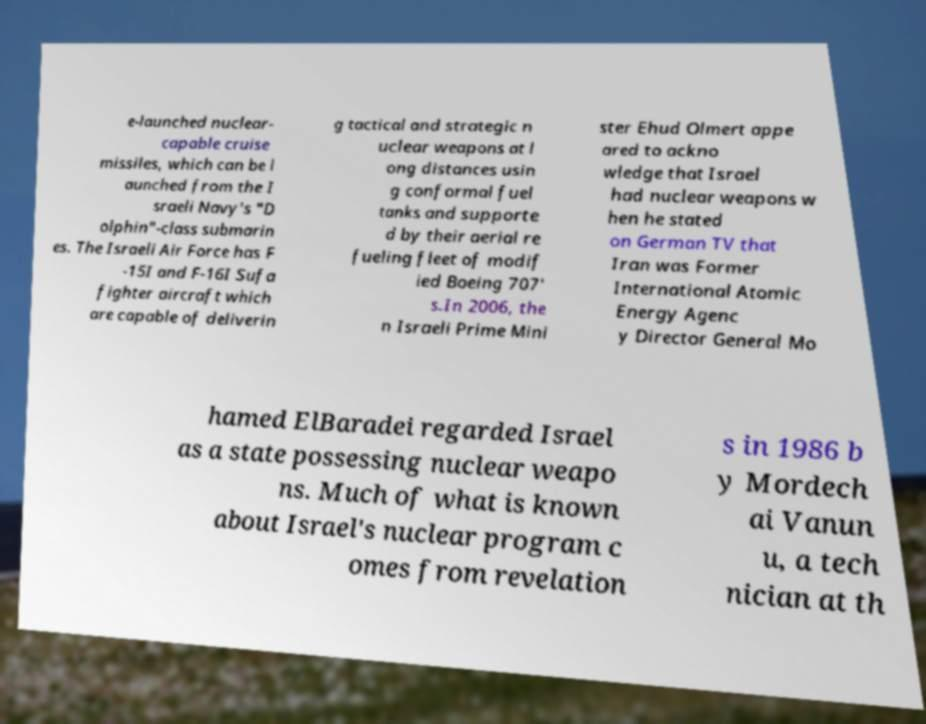For documentation purposes, I need the text within this image transcribed. Could you provide that? e-launched nuclear- capable cruise missiles, which can be l aunched from the I sraeli Navy's "D olphin"-class submarin es. The Israeli Air Force has F -15I and F-16I Sufa fighter aircraft which are capable of deliverin g tactical and strategic n uclear weapons at l ong distances usin g conformal fuel tanks and supporte d by their aerial re fueling fleet of modif ied Boeing 707' s.In 2006, the n Israeli Prime Mini ster Ehud Olmert appe ared to ackno wledge that Israel had nuclear weapons w hen he stated on German TV that Iran was Former International Atomic Energy Agenc y Director General Mo hamed ElBaradei regarded Israel as a state possessing nuclear weapo ns. Much of what is known about Israel's nuclear program c omes from revelation s in 1986 b y Mordech ai Vanun u, a tech nician at th 